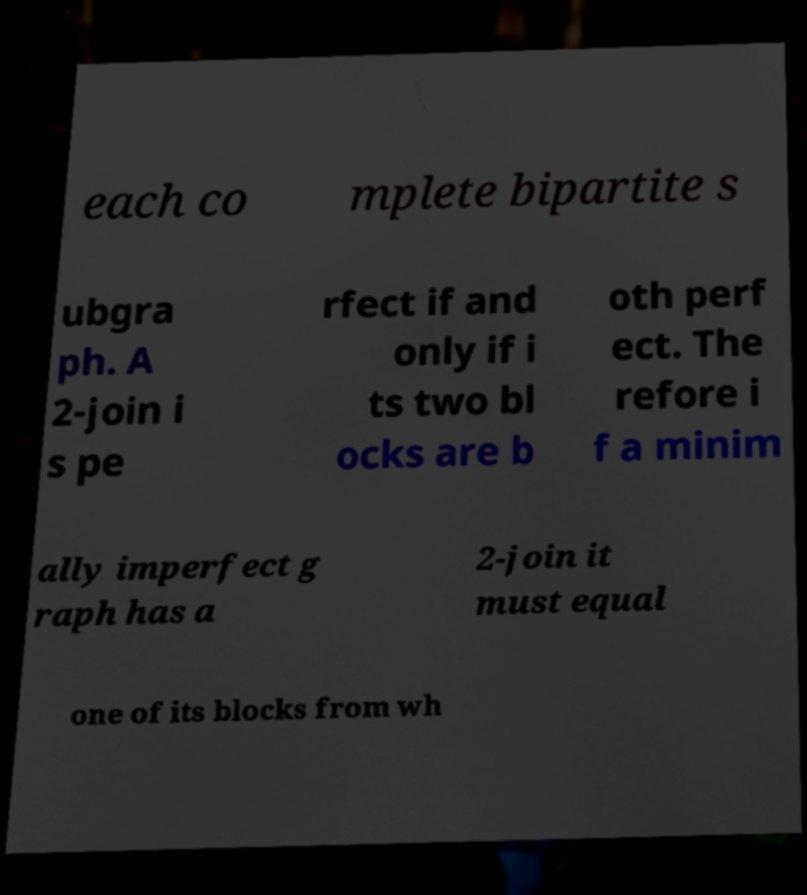For documentation purposes, I need the text within this image transcribed. Could you provide that? each co mplete bipartite s ubgra ph. A 2-join i s pe rfect if and only if i ts two bl ocks are b oth perf ect. The refore i f a minim ally imperfect g raph has a 2-join it must equal one of its blocks from wh 